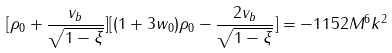Convert formula to latex. <formula><loc_0><loc_0><loc_500><loc_500>[ \rho _ { 0 } + \frac { v _ { b } } { \sqrt { 1 - \xi } } ] [ ( 1 + 3 w _ { 0 } ) \rho _ { 0 } - \frac { 2 v _ { b } } { \sqrt { 1 - \xi } } ] = - 1 1 5 2 M ^ { 6 } k ^ { 2 }</formula> 